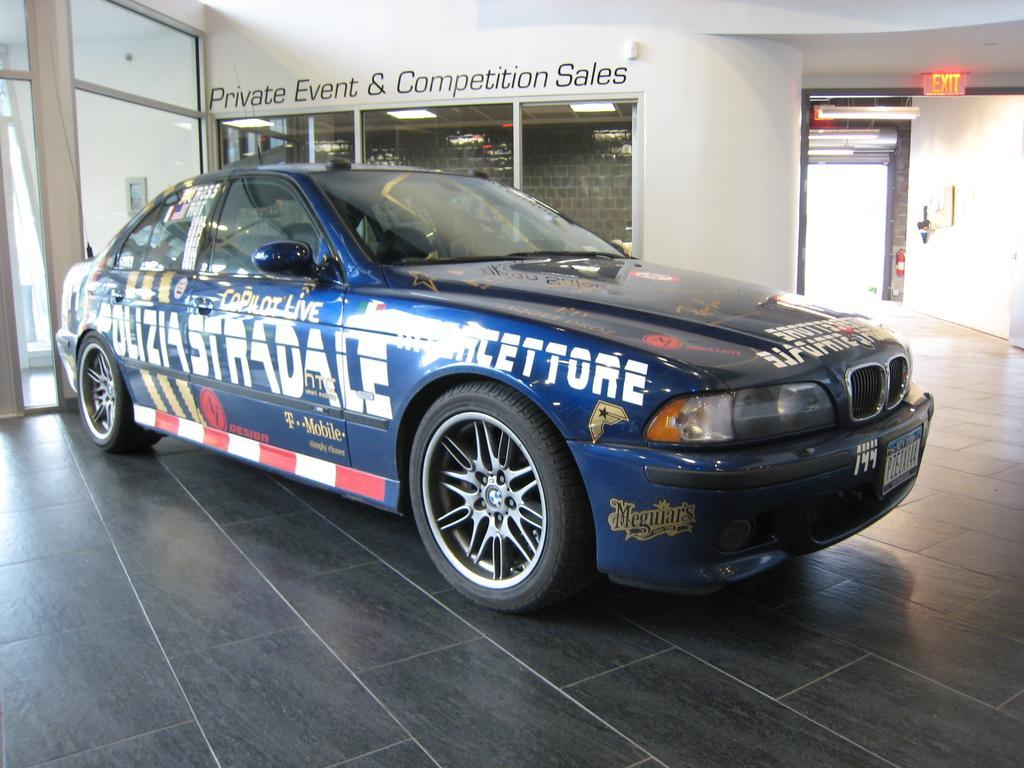Please provide a concise description of this image. In the center of the picture there is a car, behind the car there are glass windows and wall. On the right there are lights, wall and door. In the center of the background there are lights and a brick wall. 